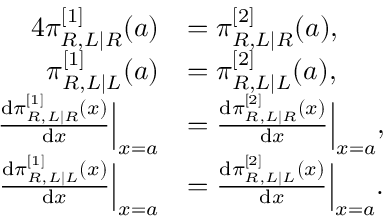Convert formula to latex. <formula><loc_0><loc_0><loc_500><loc_500>\begin{array} { r l } { { 4 } \pi _ { R , L | R } ^ { [ 1 ] } ( a ) } & { = \pi _ { R , L | R } ^ { [ 2 ] } ( a ) , } \\ { \pi _ { R , L | L } ^ { [ 1 ] } ( a ) } & { = \pi _ { R , L | L } ^ { [ 2 ] } ( a ) , } \\ { \frac { d \pi _ { R , L | R } ^ { [ 1 ] } ( x ) } { d x } \left | _ { x = a } } & { = \frac { d \pi _ { R , L | R } ^ { [ 2 ] } ( x ) } { d x } \right | _ { x = a } , } \\ { \frac { d \pi _ { R , L | L } ^ { [ 1 ] } ( x ) } { d x } \left | _ { x = a } } & { = \frac { d \pi _ { R , L | L } ^ { [ 2 ] } ( x ) } { d x } \right | _ { x = a } . } \end{array}</formula> 